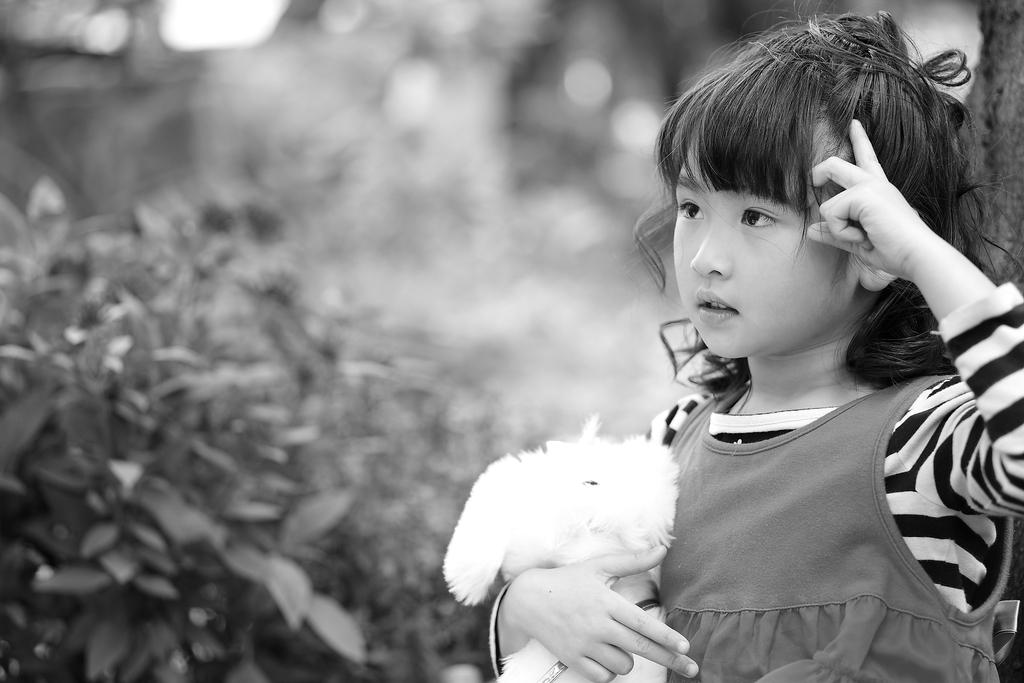Who is present in the image? There is a girl in the image. What is the girl holding in the image? The girl is holding a toy. What can be seen in the background of the image? There are leaves in the background of the image. How would you describe the background of the image? The background of the image is blurry. What type of tools does the carpenter use in the image? There is no carpenter present in the image, so it is not possible to answer that question. 